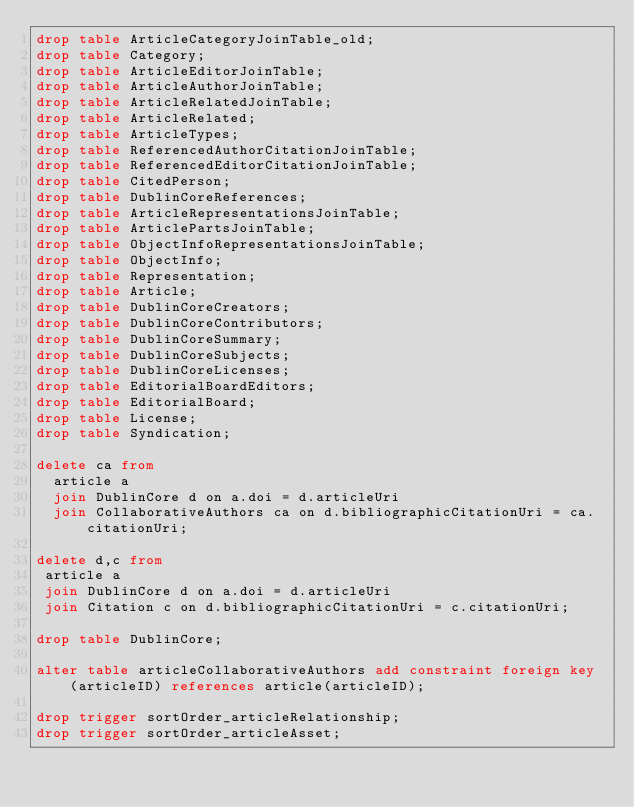Convert code to text. <code><loc_0><loc_0><loc_500><loc_500><_SQL_>drop table ArticleCategoryJoinTable_old;
drop table Category;
drop table ArticleEditorJoinTable;
drop table ArticleAuthorJoinTable;
drop table ArticleRelatedJoinTable;
drop table ArticleRelated;
drop table ArticleTypes;
drop table ReferencedAuthorCitationJoinTable;
drop table ReferencedEditorCitationJoinTable;
drop table CitedPerson;
drop table DublinCoreReferences;
drop table ArticleRepresentationsJoinTable;
drop table ArticlePartsJoinTable;
drop table ObjectInfoRepresentationsJoinTable;
drop table ObjectInfo;
drop table Representation;
drop table Article;
drop table DublinCoreCreators;
drop table DublinCoreContributors;
drop table DublinCoreSummary;
drop table DublinCoreSubjects;
drop table DublinCoreLicenses;
drop table EditorialBoardEditors;
drop table EditorialBoard;
drop table License;
drop table Syndication;

delete ca from
  article a
  join DublinCore d on a.doi = d.articleUri
  join CollaborativeAuthors ca on d.bibliographicCitationUri = ca.citationUri;

delete d,c from
 article a
 join DublinCore d on a.doi = d.articleUri
 join Citation c on d.bibliographicCitationUri = c.citationUri;

drop table DublinCore;

alter table articleCollaborativeAuthors add constraint foreign key (articleID) references article(articleID);

drop trigger sortOrder_articleRelationship;
drop trigger sortOrder_articleAsset;</code> 